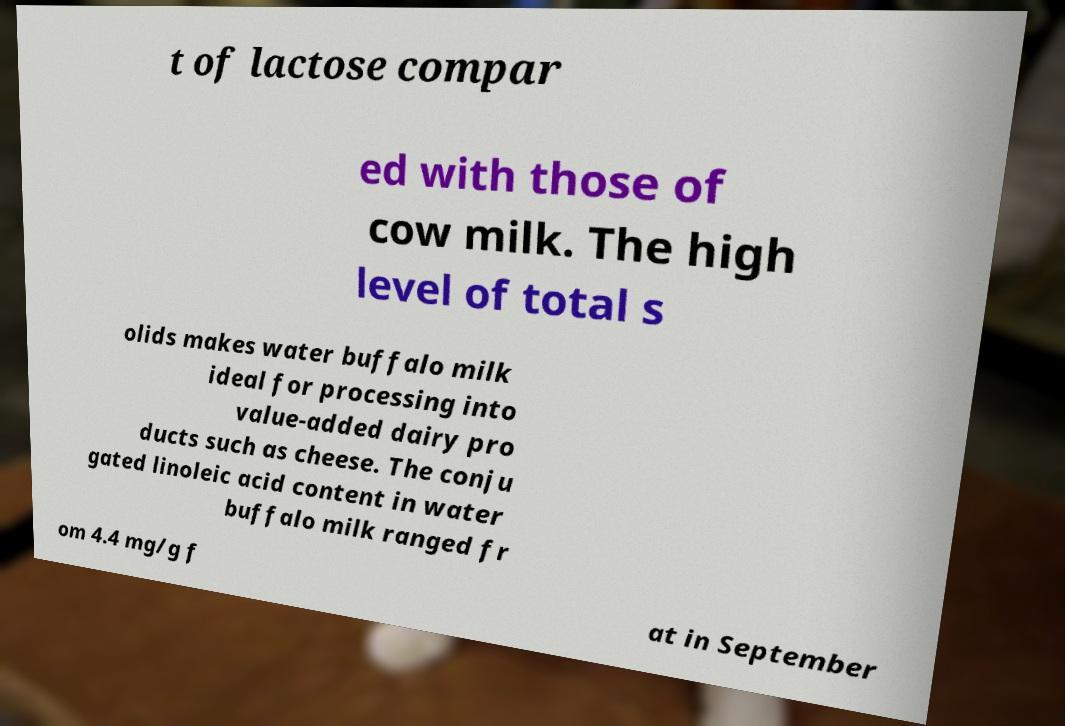I need the written content from this picture converted into text. Can you do that? t of lactose compar ed with those of cow milk. The high level of total s olids makes water buffalo milk ideal for processing into value-added dairy pro ducts such as cheese. The conju gated linoleic acid content in water buffalo milk ranged fr om 4.4 mg/g f at in September 